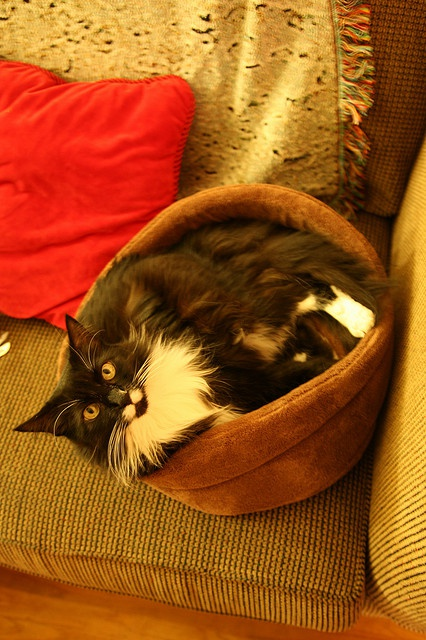Describe the objects in this image and their specific colors. I can see couch in maroon, red, black, and orange tones and cat in orange, black, maroon, gold, and olive tones in this image. 